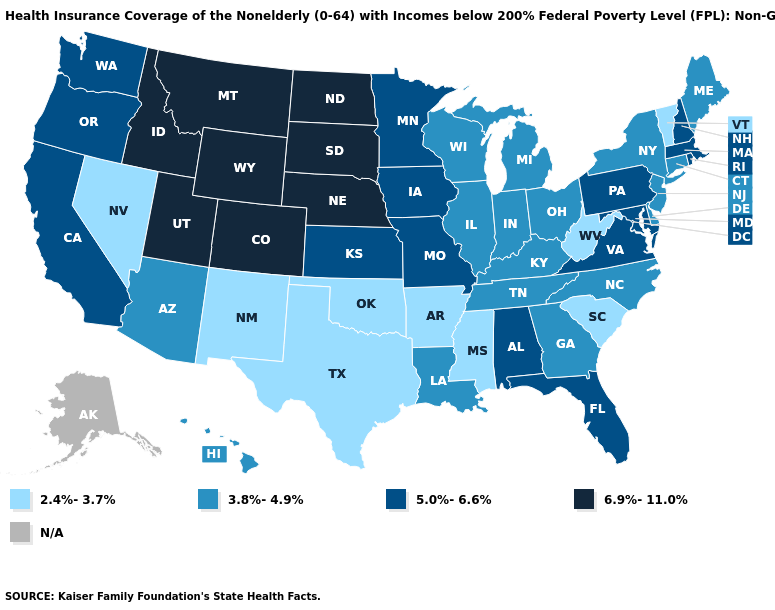Does North Carolina have the highest value in the South?
Answer briefly. No. What is the value of Montana?
Give a very brief answer. 6.9%-11.0%. Which states have the lowest value in the South?
Give a very brief answer. Arkansas, Mississippi, Oklahoma, South Carolina, Texas, West Virginia. Name the states that have a value in the range 3.8%-4.9%?
Keep it brief. Arizona, Connecticut, Delaware, Georgia, Hawaii, Illinois, Indiana, Kentucky, Louisiana, Maine, Michigan, New Jersey, New York, North Carolina, Ohio, Tennessee, Wisconsin. Is the legend a continuous bar?
Concise answer only. No. What is the value of Connecticut?
Write a very short answer. 3.8%-4.9%. Does Indiana have the highest value in the USA?
Keep it brief. No. Name the states that have a value in the range 6.9%-11.0%?
Quick response, please. Colorado, Idaho, Montana, Nebraska, North Dakota, South Dakota, Utah, Wyoming. Does Montana have the highest value in the USA?
Give a very brief answer. Yes. Name the states that have a value in the range 5.0%-6.6%?
Write a very short answer. Alabama, California, Florida, Iowa, Kansas, Maryland, Massachusetts, Minnesota, Missouri, New Hampshire, Oregon, Pennsylvania, Rhode Island, Virginia, Washington. Which states hav the highest value in the West?
Quick response, please. Colorado, Idaho, Montana, Utah, Wyoming. How many symbols are there in the legend?
Answer briefly. 5. Which states have the lowest value in the South?
Quick response, please. Arkansas, Mississippi, Oklahoma, South Carolina, Texas, West Virginia. What is the value of New Jersey?
Be succinct. 3.8%-4.9%. Which states have the lowest value in the USA?
Answer briefly. Arkansas, Mississippi, Nevada, New Mexico, Oklahoma, South Carolina, Texas, Vermont, West Virginia. 